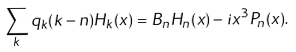Convert formula to latex. <formula><loc_0><loc_0><loc_500><loc_500>\sum _ { k } q _ { k } ( k - n ) H _ { k } ( x ) = B _ { n } H _ { n } ( x ) - i x ^ { 3 } P _ { n } ( x ) .</formula> 